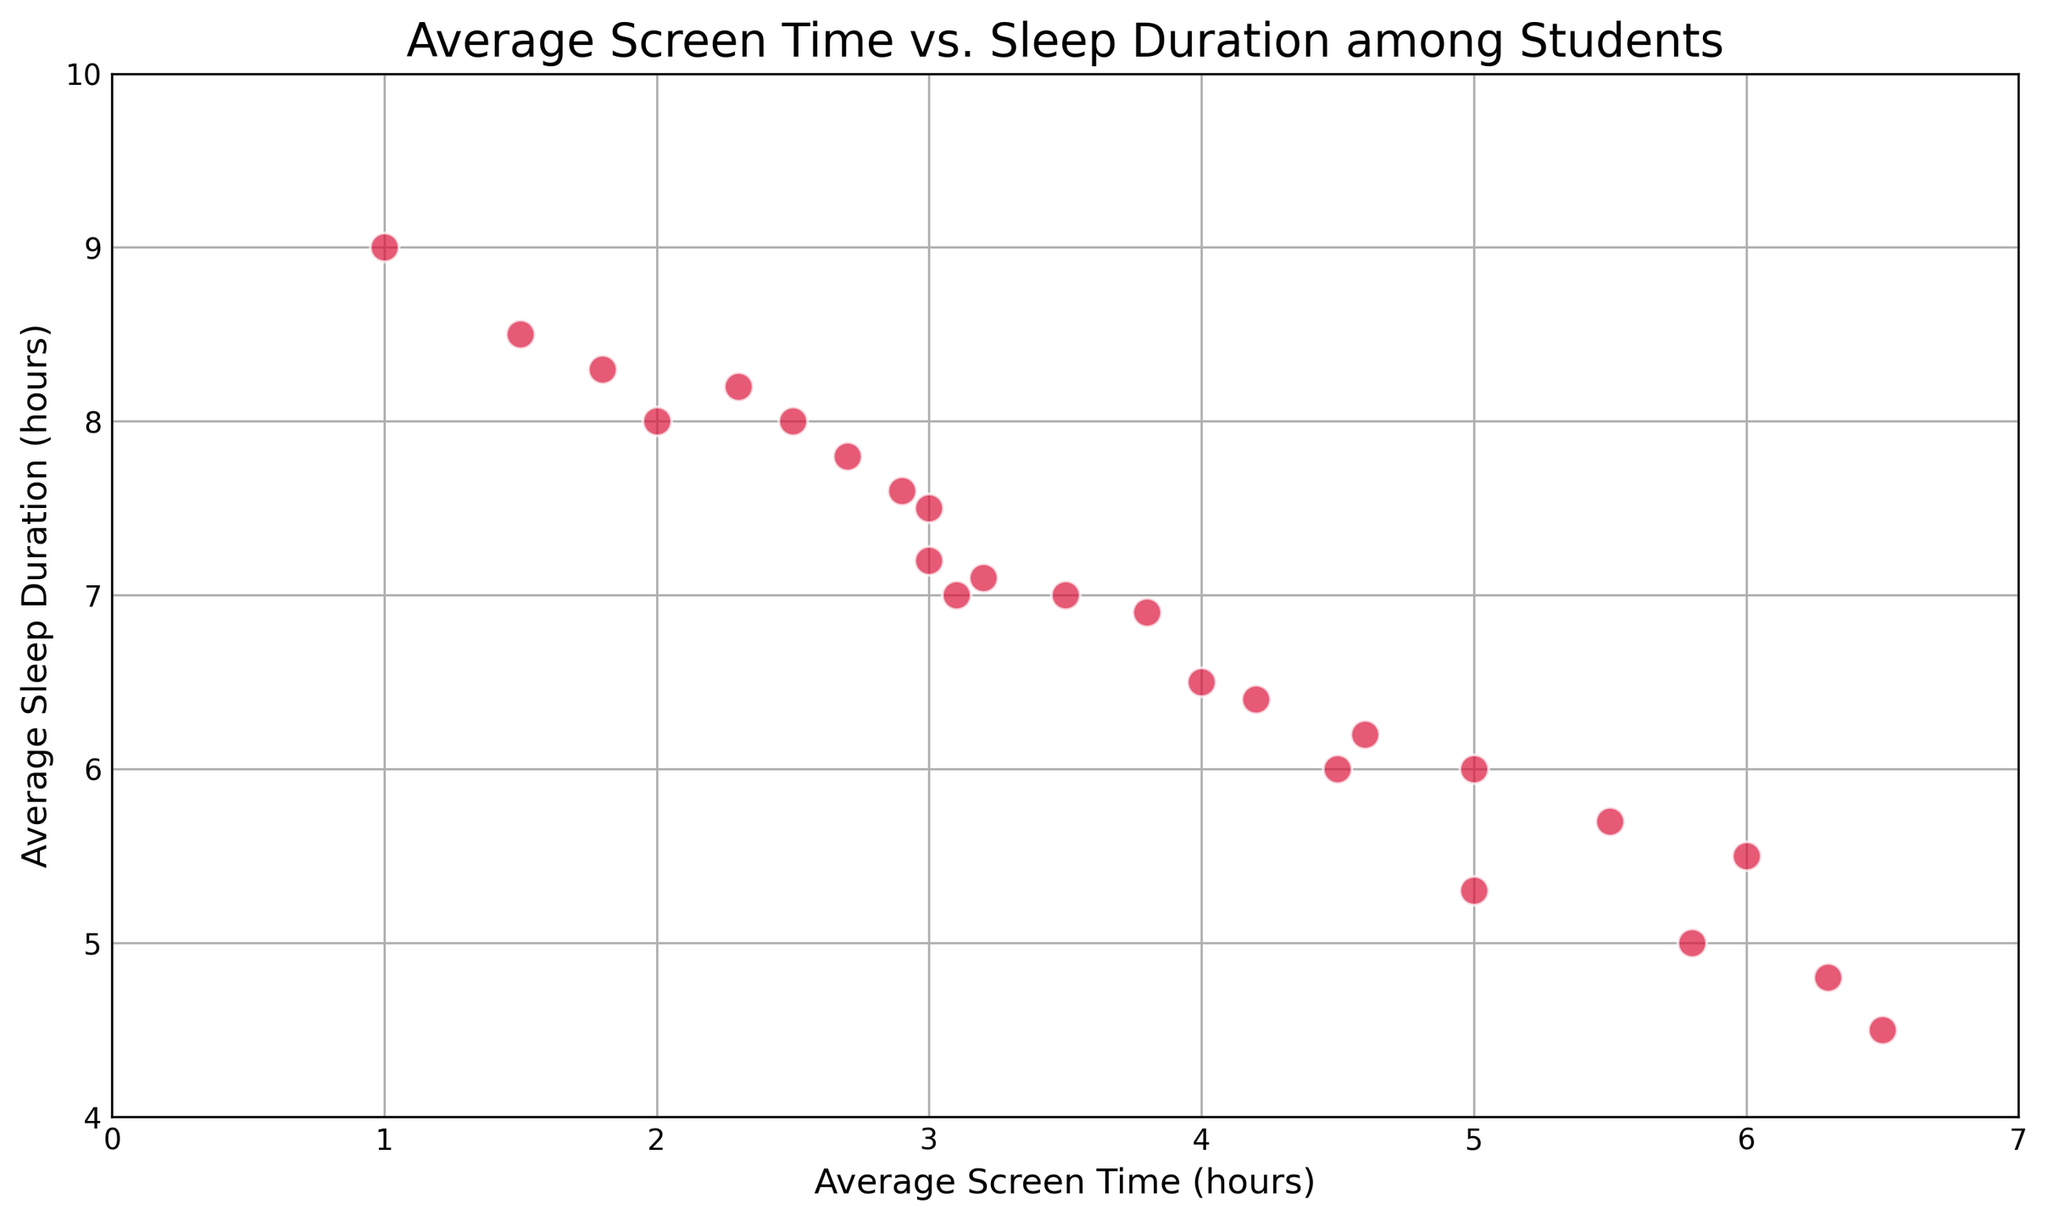How many data points are above the 6-hour mark for sleep duration? To determine the number of data points with sleep duration above 6 hours, visually inspect the y-axis and count all markers positioned above the 6-hour line.
Answer: 16 What is the range of average screen time values? The range is found by identifying the minimum and maximum values on the x-axis representing screen time. Visually, the smallest value is 1 hour and the largest is 6.5 hours. The range is the difference between these two values.
Answer: 5.5 hours Is there a general trend visible between screen time and sleep duration? By examining the scatter plot, most points tend to show an inverse relationship where increased screen time corresponds to decreased sleep duration.
Answer: Yes, inverse relationship Which student has the highest screen time, and what is their sleep duration? To identify the student with the highest screen time, find the data point farthest to the right on the x-axis. The sleep duration for this point, read from the y-axis, is 4.5 hours.
Answer: 6.5 hours screen time and 4.5 hours sleep What is the sleep duration for the student with an average screen time of 2.9 hours? Locate the point directly at 2.9 hours on the x-axis, then read the corresponding value from the y-axis.
Answer: 7.6 hours How many students have less than 7 hours of sleep? Count the data points that appear below the 7-hour mark on the y-axis.
Answer: 8 What's the average sleep duration for students with more than 5 hours of screen time? Identify the data points with more than 5 hours of screen time (x > 5), then average their corresponding y-values for sleep duration. Points are at (5.5, 5.7), (5.8, 5), (6, 5.5), (6.3, 4.8), (6.5, 4.5): (5.7+5+5.5+4.8+4.5)/5 = 25.5/5 = 5.1 hours.
Answer: 5.1 hours Compare the sleep duration between students with 2 hours and 4 hours of screen time. Locate the data points at 2 hours and 4 hours on the x-axis, and then read their respective y-values for sleep duration: 8 hours (2) and 6.5 hours (4).
Answer: 2 hours - 8 hours, 4 hours - 6.5 hours Determine the sleep duration difference between students with the maximum and minimum screen times. Identify points at maximum (6.5 hours of screen time, 4.5 hours sleep) and minimum (1 hour of screen time, 9 hours sleep) values, then calculate the difference: 9 - 4.5 = 4.5 hours.
Answer: 4.5 hours How many students have at least 5 hours of screen time? Count the points starting from 5 hours onward on the x-axis.
Answer: 6 